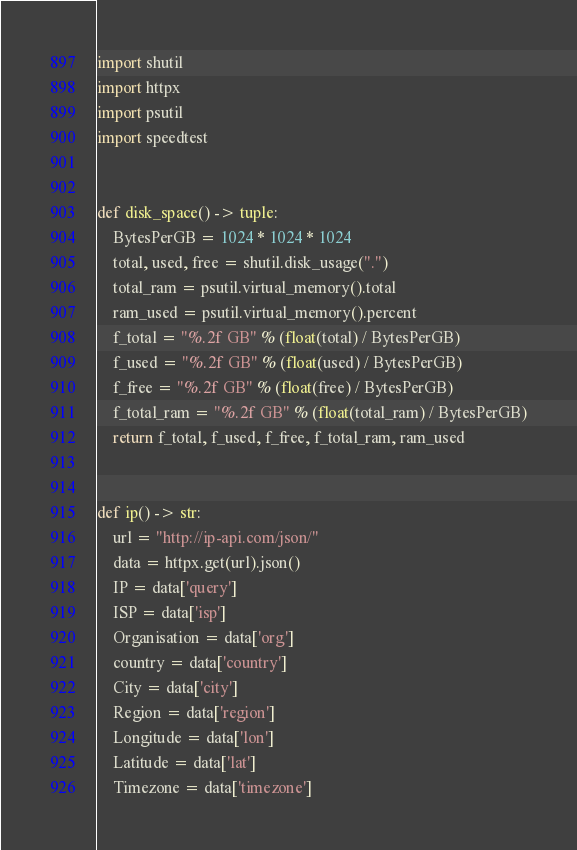<code> <loc_0><loc_0><loc_500><loc_500><_Python_>import shutil
import httpx
import psutil
import speedtest


def disk_space() -> tuple:
    BytesPerGB = 1024 * 1024 * 1024
    total, used, free = shutil.disk_usage(".")
    total_ram = psutil.virtual_memory().total
    ram_used = psutil.virtual_memory().percent
    f_total = "%.2f GB" % (float(total) / BytesPerGB)
    f_used = "%.2f GB" % (float(used) / BytesPerGB)
    f_free = "%.2f GB" % (float(free) / BytesPerGB)
    f_total_ram = "%.2f GB" % (float(total_ram) / BytesPerGB)
    return f_total, f_used, f_free, f_total_ram, ram_used


def ip() -> str:
    url = "http://ip-api.com/json/"
    data = httpx.get(url).json()
    IP = data['query']
    ISP = data['isp']
    Organisation = data['org']
    country = data['country']
    City = data['city']
    Region = data['region']
    Longitude = data['lon']
    Latitude = data['lat']
    Timezone = data['timezone']</code> 